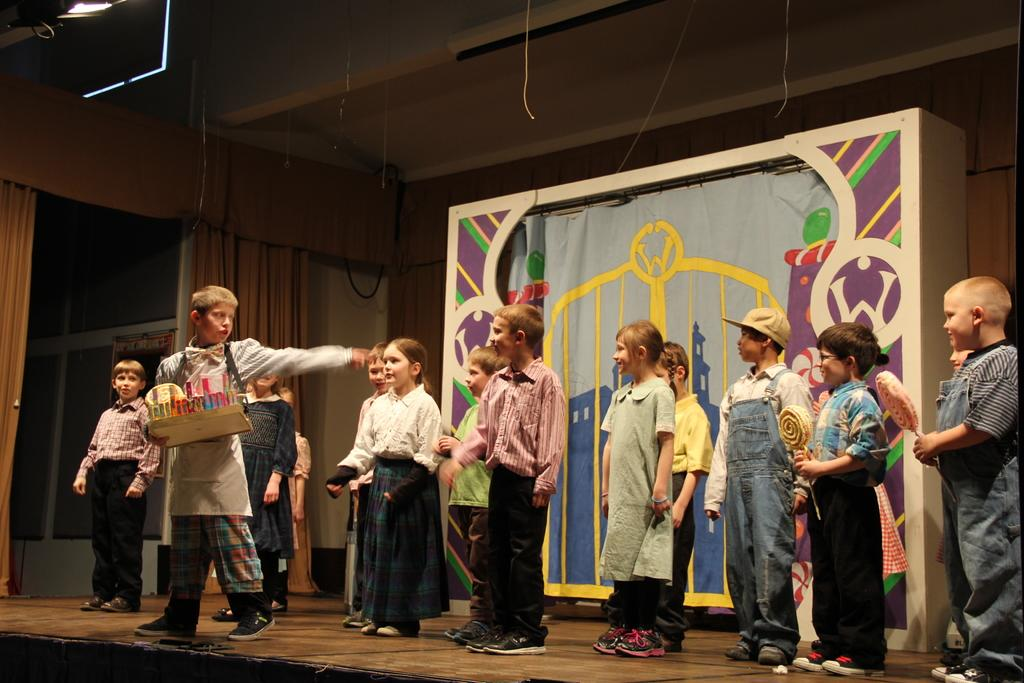What is happening on the stage in the image? There are children on the stage in the image. What can be seen in the background behind the stage? There is a curtain in the background. What provides shelter or protection in the image? There is a roof for shelter at the top. What are the people holding or interacting with in the image? There are people with objects in the image. How many boats are visible in the image? There are no boats present in the image. What level of excitement can be expected from the attraction in the image? There is no attraction present in the image. 